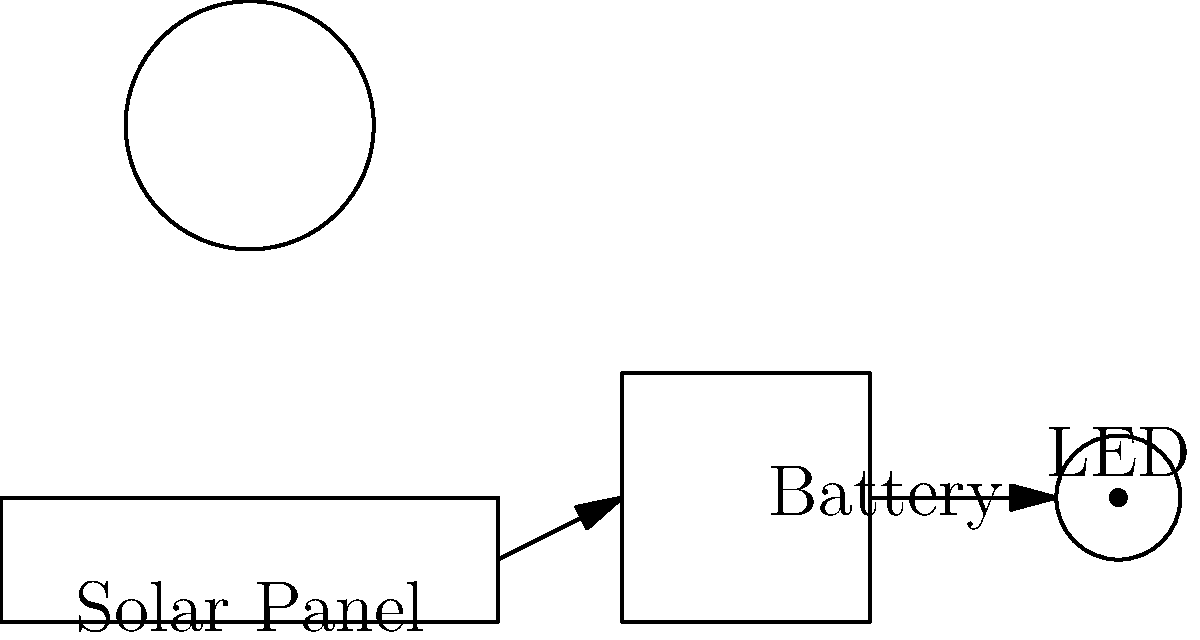During your morning walk in the professor's garden, you notice a solar-powered garden lamp. The lamp consists of a solar panel, a battery, and an LED. If the solar panel receives $100\text{ W/m}^2$ of solar radiation and has an area of $0.02\text{ m}^2$, what is the maximum power that can be transferred to the battery, assuming the solar panel has an efficiency of $15\%$? To solve this problem, let's follow these steps:

1. Calculate the total power received by the solar panel:
   * Power density of solar radiation = $100\text{ W/m}^2$
   * Area of solar panel = $0.02\text{ m}^2$
   * Total power received = $100\text{ W/m}^2 \times 0.02\text{ m}^2 = 2\text{ W}$

2. Account for the efficiency of the solar panel:
   * Efficiency = $15\% = 0.15$
   * Maximum power transferred = Total power received $\times$ Efficiency
   * Maximum power transferred = $2\text{ W} \times 0.15 = 0.3\text{ W}$

The maximum power that can be transferred to the battery is $0.3\text{ W}$ or $300\text{ mW}$.
Answer: $0.3\text{ W}$ 